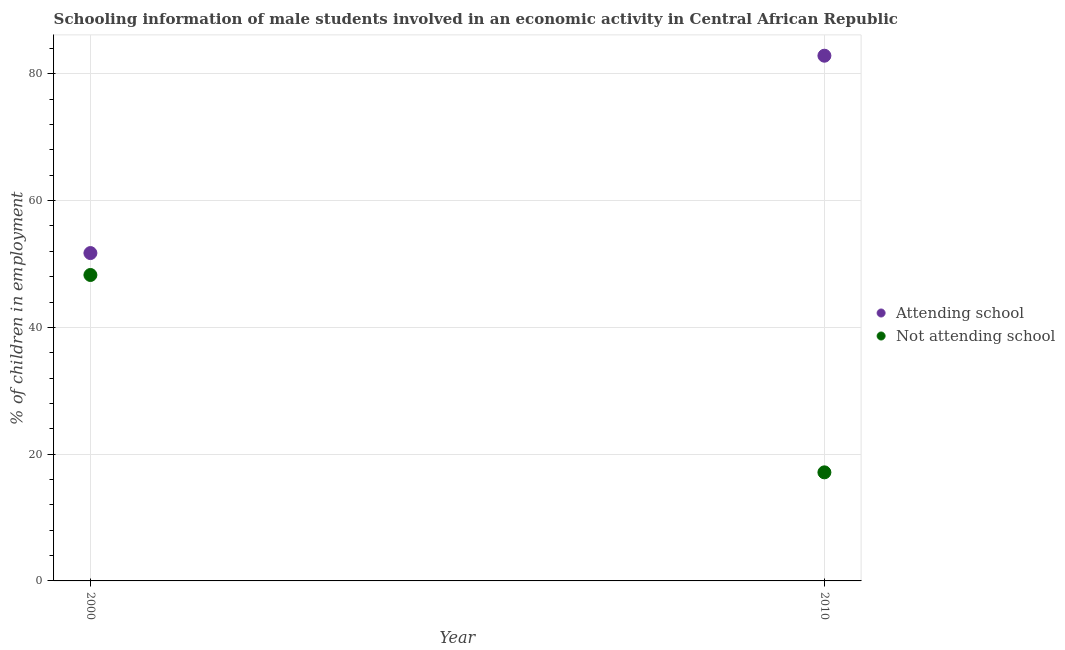What is the percentage of employed males who are attending school in 2010?
Make the answer very short. 82.87. Across all years, what is the maximum percentage of employed males who are attending school?
Your response must be concise. 82.87. Across all years, what is the minimum percentage of employed males who are not attending school?
Keep it short and to the point. 17.13. In which year was the percentage of employed males who are attending school maximum?
Your answer should be very brief. 2010. What is the total percentage of employed males who are not attending school in the graph?
Provide a succinct answer. 65.4. What is the difference between the percentage of employed males who are attending school in 2000 and that in 2010?
Provide a succinct answer. -31.14. What is the difference between the percentage of employed males who are not attending school in 2010 and the percentage of employed males who are attending school in 2000?
Your answer should be very brief. -34.6. What is the average percentage of employed males who are attending school per year?
Keep it short and to the point. 67.3. In the year 2010, what is the difference between the percentage of employed males who are not attending school and percentage of employed males who are attending school?
Give a very brief answer. -65.74. In how many years, is the percentage of employed males who are not attending school greater than 44 %?
Give a very brief answer. 1. What is the ratio of the percentage of employed males who are attending school in 2000 to that in 2010?
Provide a short and direct response. 0.62. Is the percentage of employed males who are attending school in 2000 less than that in 2010?
Give a very brief answer. Yes. Does the percentage of employed males who are not attending school monotonically increase over the years?
Provide a succinct answer. No. Are the values on the major ticks of Y-axis written in scientific E-notation?
Ensure brevity in your answer.  No. Does the graph contain any zero values?
Give a very brief answer. No. Where does the legend appear in the graph?
Provide a succinct answer. Center right. What is the title of the graph?
Your answer should be compact. Schooling information of male students involved in an economic activity in Central African Republic. What is the label or title of the Y-axis?
Your response must be concise. % of children in employment. What is the % of children in employment of Attending school in 2000?
Provide a short and direct response. 51.73. What is the % of children in employment of Not attending school in 2000?
Your response must be concise. 48.27. What is the % of children in employment in Attending school in 2010?
Keep it short and to the point. 82.87. What is the % of children in employment in Not attending school in 2010?
Your answer should be very brief. 17.13. Across all years, what is the maximum % of children in employment in Attending school?
Provide a succinct answer. 82.87. Across all years, what is the maximum % of children in employment in Not attending school?
Provide a succinct answer. 48.27. Across all years, what is the minimum % of children in employment of Attending school?
Your answer should be very brief. 51.73. Across all years, what is the minimum % of children in employment of Not attending school?
Provide a short and direct response. 17.13. What is the total % of children in employment in Attending school in the graph?
Your response must be concise. 134.6. What is the total % of children in employment of Not attending school in the graph?
Your answer should be compact. 65.4. What is the difference between the % of children in employment of Attending school in 2000 and that in 2010?
Make the answer very short. -31.14. What is the difference between the % of children in employment of Not attending school in 2000 and that in 2010?
Your answer should be very brief. 31.14. What is the difference between the % of children in employment of Attending school in 2000 and the % of children in employment of Not attending school in 2010?
Give a very brief answer. 34.6. What is the average % of children in employment in Attending school per year?
Make the answer very short. 67.3. What is the average % of children in employment of Not attending school per year?
Make the answer very short. 32.7. In the year 2000, what is the difference between the % of children in employment in Attending school and % of children in employment in Not attending school?
Give a very brief answer. 3.46. In the year 2010, what is the difference between the % of children in employment in Attending school and % of children in employment in Not attending school?
Provide a short and direct response. 65.74. What is the ratio of the % of children in employment in Attending school in 2000 to that in 2010?
Your answer should be compact. 0.62. What is the ratio of the % of children in employment of Not attending school in 2000 to that in 2010?
Provide a short and direct response. 2.82. What is the difference between the highest and the second highest % of children in employment of Attending school?
Give a very brief answer. 31.14. What is the difference between the highest and the second highest % of children in employment of Not attending school?
Provide a succinct answer. 31.14. What is the difference between the highest and the lowest % of children in employment in Attending school?
Provide a succinct answer. 31.14. What is the difference between the highest and the lowest % of children in employment of Not attending school?
Provide a short and direct response. 31.14. 